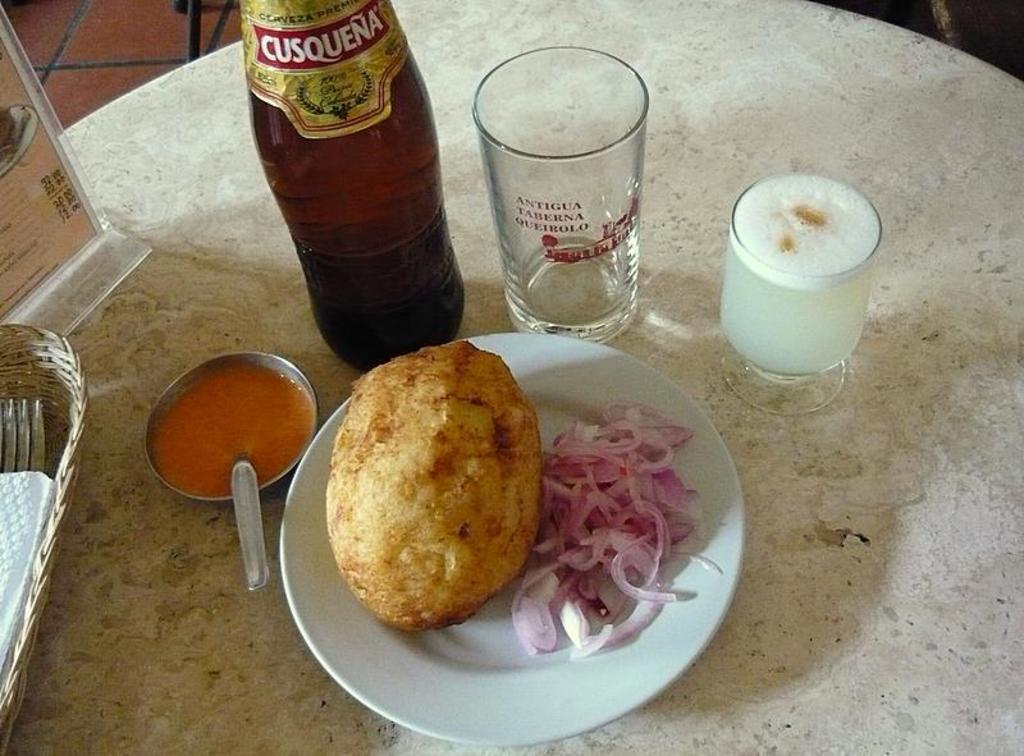Please provide a concise description of this image. In this image I can see the white colored table and on the table I can see two glasses, a bottle, a bowl with soup in it and a white colored plate. In the plate I can see a food item which is brown and cream in color and few onion pieces. 